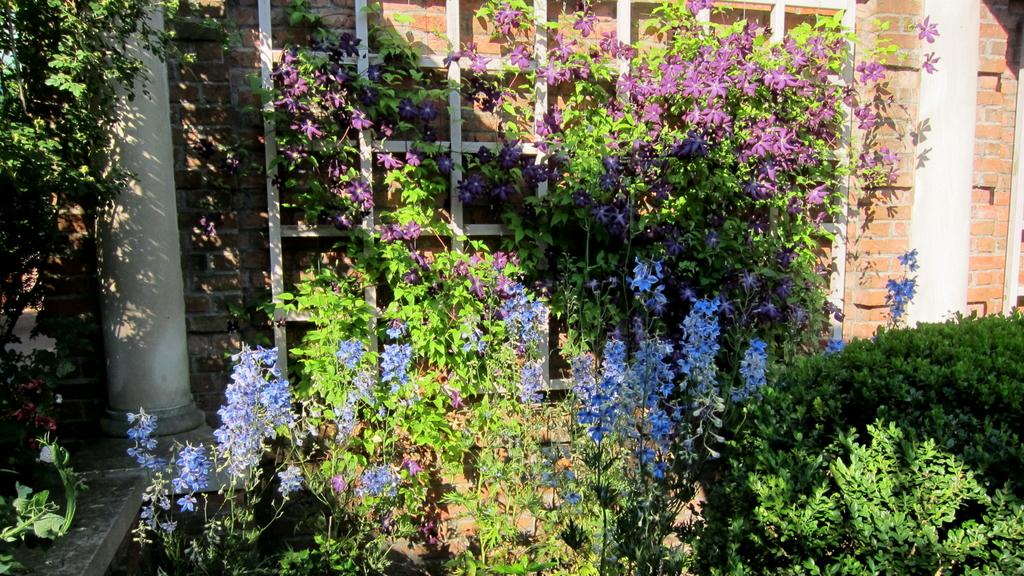What colors are the flowers in the image? The flowers in the image are blue and purple. Where are the flowers located? The flowers are on plants. What other vegetation can be seen in the image? There are shrubs in the image. What architectural features are visible in the background? There are pillars and a brick wall in the background of the image. Can you see the actor saying good-bye to the rat in the image? There is no actor or rat present in the image. 